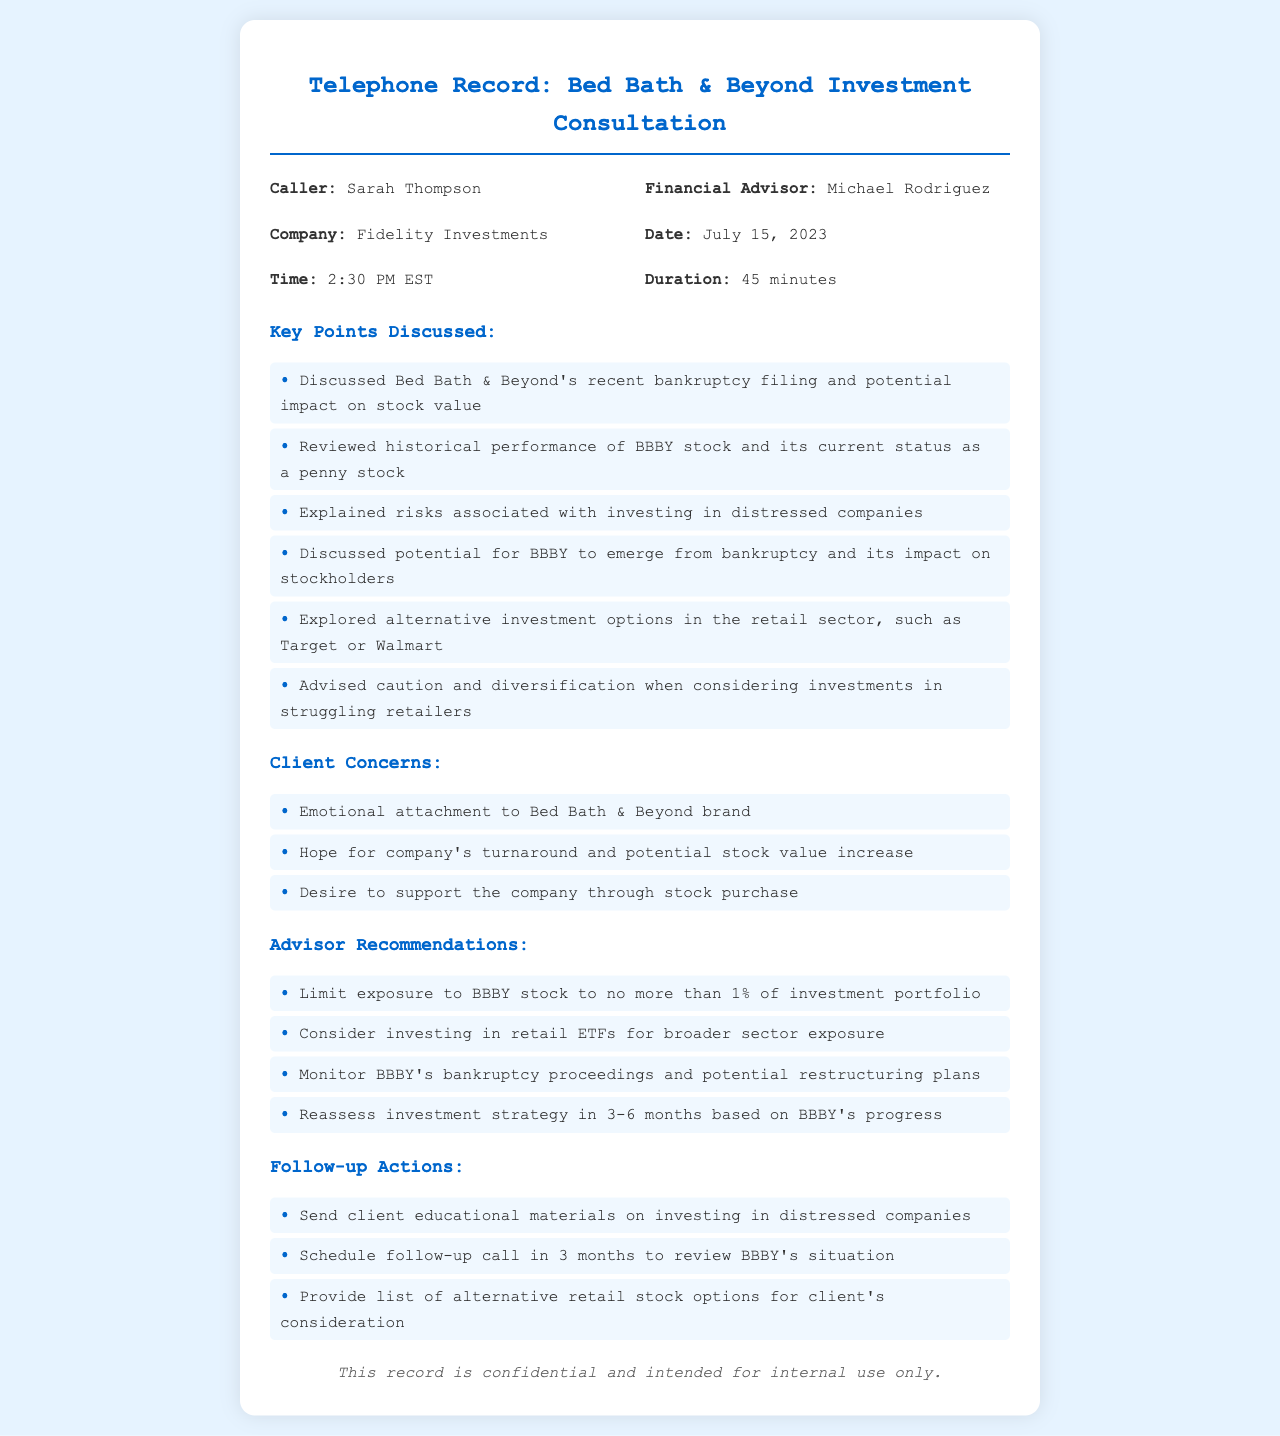what is the name of the caller? The caller's name is mentioned at the beginning of the document.
Answer: Sarah Thompson who is the financial advisor? The financial advisor's name is listed alongside the caller's information.
Answer: Michael Rodriguez what was the duration of the consultation? The duration is specified in the consultation details.
Answer: 45 minutes what is the date of the phone consultation? The date is explicitly stated in the document header.
Answer: July 15, 2023 what is one key point discussed during the consultation? The key points discussed are listed in a bullet format.
Answer: Discussed Bed Bath & Beyond's recent bankruptcy filing and potential impact on stock value what percentage should exposure to BBBY stock be limited to? The document provides a recommendation regarding investment portfolio exposure.
Answer: no more than 1% what alternative companies were mentioned for investment? The advisor explored other options during the consultation.
Answer: Target or Walmart what client concern relates to emotional attachment? The document specifies a concern due to brand attachment.
Answer: Emotional attachment to Bed Bath & Beyond brand when is the follow-up call scheduled? The document mentions a timeframe for the follow-up action.
Answer: in 3 months 